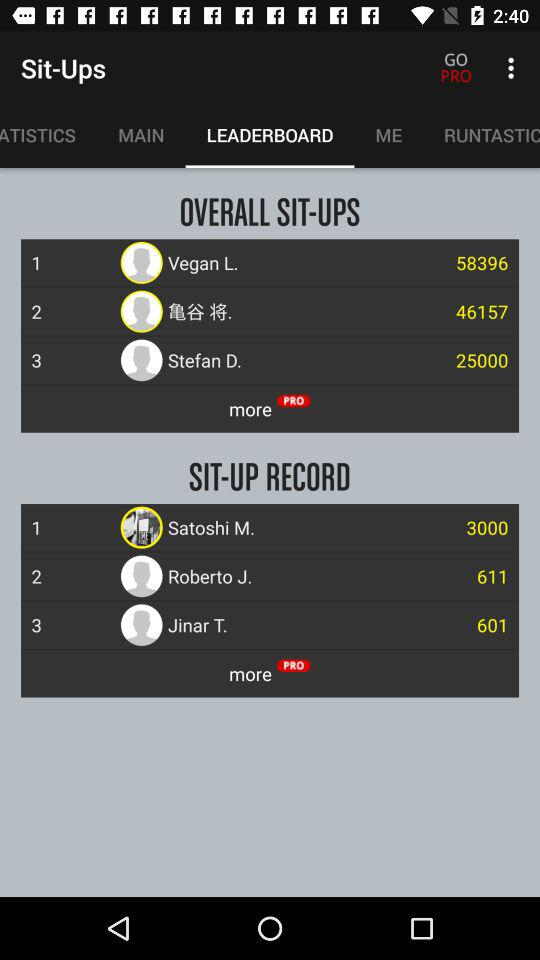What is the sit-up record of Satoshi M.? The sit-up record of Satoshi M. is 3000. 